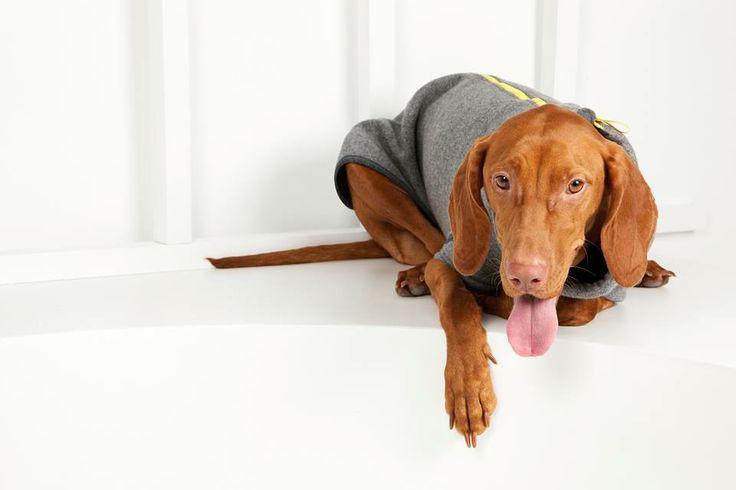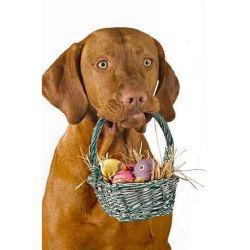The first image is the image on the left, the second image is the image on the right. Evaluate the accuracy of this statement regarding the images: "A dog is wearing a knit hat.". Is it true? Answer yes or no. No. The first image is the image on the left, the second image is the image on the right. Assess this claim about the two images: "The right image contains a brown dog that is wearing clothing on their head.". Correct or not? Answer yes or no. No. 